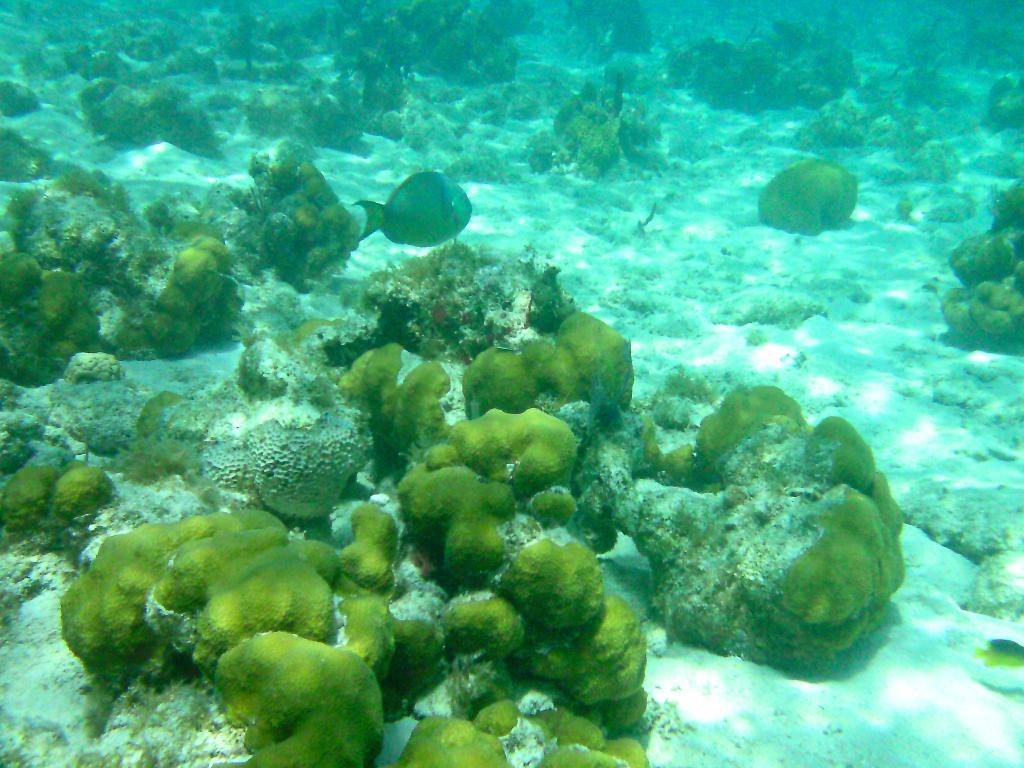What is happening in the water in the image? There are fishes swimming in the water. What type of natural elements can be seen in the image? There are rocks and sand in the image. How many ladybugs can be seen crawling on the rocks in the image? There are no ladybugs present in the image; it only features fishes swimming in the water, rocks, and sand. 